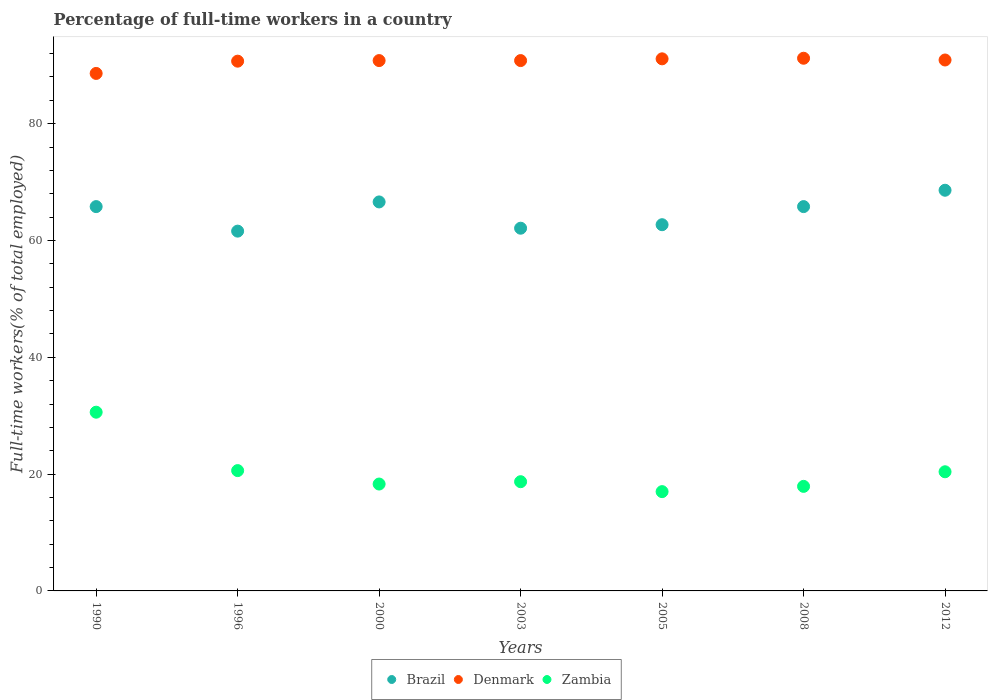Is the number of dotlines equal to the number of legend labels?
Provide a succinct answer. Yes. What is the percentage of full-time workers in Zambia in 2005?
Give a very brief answer. 17. Across all years, what is the maximum percentage of full-time workers in Zambia?
Provide a short and direct response. 30.6. Across all years, what is the minimum percentage of full-time workers in Denmark?
Your response must be concise. 88.6. What is the total percentage of full-time workers in Zambia in the graph?
Ensure brevity in your answer.  143.5. What is the difference between the percentage of full-time workers in Zambia in 2005 and that in 2012?
Offer a very short reply. -3.4. What is the difference between the percentage of full-time workers in Zambia in 2000 and the percentage of full-time workers in Brazil in 2012?
Provide a short and direct response. -50.3. What is the average percentage of full-time workers in Denmark per year?
Offer a terse response. 90.59. In the year 2005, what is the difference between the percentage of full-time workers in Zambia and percentage of full-time workers in Denmark?
Your answer should be very brief. -74.1. In how many years, is the percentage of full-time workers in Brazil greater than 48 %?
Offer a very short reply. 7. What is the ratio of the percentage of full-time workers in Denmark in 2005 to that in 2008?
Give a very brief answer. 1. Is the percentage of full-time workers in Denmark in 2000 less than that in 2003?
Keep it short and to the point. No. Is the difference between the percentage of full-time workers in Zambia in 1996 and 2000 greater than the difference between the percentage of full-time workers in Denmark in 1996 and 2000?
Give a very brief answer. Yes. What is the difference between the highest and the lowest percentage of full-time workers in Zambia?
Give a very brief answer. 13.6. Is the sum of the percentage of full-time workers in Zambia in 2008 and 2012 greater than the maximum percentage of full-time workers in Brazil across all years?
Provide a short and direct response. No. Does the percentage of full-time workers in Denmark monotonically increase over the years?
Offer a very short reply. No. Is the percentage of full-time workers in Brazil strictly less than the percentage of full-time workers in Zambia over the years?
Offer a very short reply. No. How many dotlines are there?
Your response must be concise. 3. How many years are there in the graph?
Offer a very short reply. 7. Where does the legend appear in the graph?
Provide a succinct answer. Bottom center. How many legend labels are there?
Ensure brevity in your answer.  3. What is the title of the graph?
Make the answer very short. Percentage of full-time workers in a country. What is the label or title of the X-axis?
Give a very brief answer. Years. What is the label or title of the Y-axis?
Keep it short and to the point. Full-time workers(% of total employed). What is the Full-time workers(% of total employed) in Brazil in 1990?
Provide a succinct answer. 65.8. What is the Full-time workers(% of total employed) of Denmark in 1990?
Your answer should be compact. 88.6. What is the Full-time workers(% of total employed) in Zambia in 1990?
Your answer should be compact. 30.6. What is the Full-time workers(% of total employed) in Brazil in 1996?
Offer a terse response. 61.6. What is the Full-time workers(% of total employed) in Denmark in 1996?
Provide a short and direct response. 90.7. What is the Full-time workers(% of total employed) in Zambia in 1996?
Provide a succinct answer. 20.6. What is the Full-time workers(% of total employed) in Brazil in 2000?
Offer a very short reply. 66.6. What is the Full-time workers(% of total employed) in Denmark in 2000?
Give a very brief answer. 90.8. What is the Full-time workers(% of total employed) of Zambia in 2000?
Offer a very short reply. 18.3. What is the Full-time workers(% of total employed) in Brazil in 2003?
Keep it short and to the point. 62.1. What is the Full-time workers(% of total employed) in Denmark in 2003?
Offer a very short reply. 90.8. What is the Full-time workers(% of total employed) in Zambia in 2003?
Keep it short and to the point. 18.7. What is the Full-time workers(% of total employed) in Brazil in 2005?
Your answer should be very brief. 62.7. What is the Full-time workers(% of total employed) in Denmark in 2005?
Give a very brief answer. 91.1. What is the Full-time workers(% of total employed) in Zambia in 2005?
Make the answer very short. 17. What is the Full-time workers(% of total employed) of Brazil in 2008?
Provide a short and direct response. 65.8. What is the Full-time workers(% of total employed) in Denmark in 2008?
Your response must be concise. 91.2. What is the Full-time workers(% of total employed) in Zambia in 2008?
Offer a terse response. 17.9. What is the Full-time workers(% of total employed) in Brazil in 2012?
Your answer should be very brief. 68.6. What is the Full-time workers(% of total employed) of Denmark in 2012?
Make the answer very short. 90.9. What is the Full-time workers(% of total employed) in Zambia in 2012?
Your answer should be very brief. 20.4. Across all years, what is the maximum Full-time workers(% of total employed) of Brazil?
Make the answer very short. 68.6. Across all years, what is the maximum Full-time workers(% of total employed) of Denmark?
Make the answer very short. 91.2. Across all years, what is the maximum Full-time workers(% of total employed) in Zambia?
Ensure brevity in your answer.  30.6. Across all years, what is the minimum Full-time workers(% of total employed) of Brazil?
Give a very brief answer. 61.6. Across all years, what is the minimum Full-time workers(% of total employed) in Denmark?
Your answer should be compact. 88.6. Across all years, what is the minimum Full-time workers(% of total employed) of Zambia?
Ensure brevity in your answer.  17. What is the total Full-time workers(% of total employed) in Brazil in the graph?
Keep it short and to the point. 453.2. What is the total Full-time workers(% of total employed) in Denmark in the graph?
Provide a short and direct response. 634.1. What is the total Full-time workers(% of total employed) of Zambia in the graph?
Your response must be concise. 143.5. What is the difference between the Full-time workers(% of total employed) of Brazil in 1990 and that in 1996?
Keep it short and to the point. 4.2. What is the difference between the Full-time workers(% of total employed) in Denmark in 1990 and that in 1996?
Offer a very short reply. -2.1. What is the difference between the Full-time workers(% of total employed) of Denmark in 1990 and that in 2000?
Give a very brief answer. -2.2. What is the difference between the Full-time workers(% of total employed) in Zambia in 1990 and that in 2003?
Your answer should be very brief. 11.9. What is the difference between the Full-time workers(% of total employed) of Brazil in 1990 and that in 2005?
Your answer should be very brief. 3.1. What is the difference between the Full-time workers(% of total employed) of Denmark in 1990 and that in 2005?
Offer a terse response. -2.5. What is the difference between the Full-time workers(% of total employed) of Zambia in 1990 and that in 2005?
Provide a succinct answer. 13.6. What is the difference between the Full-time workers(% of total employed) in Brazil in 1990 and that in 2008?
Ensure brevity in your answer.  0. What is the difference between the Full-time workers(% of total employed) in Zambia in 1990 and that in 2008?
Keep it short and to the point. 12.7. What is the difference between the Full-time workers(% of total employed) in Brazil in 1990 and that in 2012?
Make the answer very short. -2.8. What is the difference between the Full-time workers(% of total employed) in Denmark in 1990 and that in 2012?
Your answer should be very brief. -2.3. What is the difference between the Full-time workers(% of total employed) in Brazil in 1996 and that in 2000?
Offer a very short reply. -5. What is the difference between the Full-time workers(% of total employed) in Zambia in 1996 and that in 2000?
Your response must be concise. 2.3. What is the difference between the Full-time workers(% of total employed) in Brazil in 1996 and that in 2003?
Your answer should be very brief. -0.5. What is the difference between the Full-time workers(% of total employed) of Denmark in 1996 and that in 2003?
Offer a terse response. -0.1. What is the difference between the Full-time workers(% of total employed) of Denmark in 1996 and that in 2005?
Give a very brief answer. -0.4. What is the difference between the Full-time workers(% of total employed) in Brazil in 1996 and that in 2008?
Offer a very short reply. -4.2. What is the difference between the Full-time workers(% of total employed) in Brazil in 1996 and that in 2012?
Your response must be concise. -7. What is the difference between the Full-time workers(% of total employed) of Denmark in 1996 and that in 2012?
Offer a very short reply. -0.2. What is the difference between the Full-time workers(% of total employed) of Zambia in 1996 and that in 2012?
Keep it short and to the point. 0.2. What is the difference between the Full-time workers(% of total employed) in Denmark in 2000 and that in 2003?
Make the answer very short. 0. What is the difference between the Full-time workers(% of total employed) of Denmark in 2000 and that in 2005?
Keep it short and to the point. -0.3. What is the difference between the Full-time workers(% of total employed) in Zambia in 2000 and that in 2005?
Your answer should be compact. 1.3. What is the difference between the Full-time workers(% of total employed) in Zambia in 2000 and that in 2008?
Offer a very short reply. 0.4. What is the difference between the Full-time workers(% of total employed) in Denmark in 2000 and that in 2012?
Give a very brief answer. -0.1. What is the difference between the Full-time workers(% of total employed) of Brazil in 2003 and that in 2005?
Provide a succinct answer. -0.6. What is the difference between the Full-time workers(% of total employed) in Zambia in 2003 and that in 2005?
Make the answer very short. 1.7. What is the difference between the Full-time workers(% of total employed) in Brazil in 2003 and that in 2008?
Give a very brief answer. -3.7. What is the difference between the Full-time workers(% of total employed) of Denmark in 2003 and that in 2008?
Ensure brevity in your answer.  -0.4. What is the difference between the Full-time workers(% of total employed) of Zambia in 2003 and that in 2012?
Ensure brevity in your answer.  -1.7. What is the difference between the Full-time workers(% of total employed) in Denmark in 2005 and that in 2008?
Give a very brief answer. -0.1. What is the difference between the Full-time workers(% of total employed) in Zambia in 2005 and that in 2008?
Offer a very short reply. -0.9. What is the difference between the Full-time workers(% of total employed) of Brazil in 2005 and that in 2012?
Offer a terse response. -5.9. What is the difference between the Full-time workers(% of total employed) in Zambia in 2005 and that in 2012?
Your answer should be very brief. -3.4. What is the difference between the Full-time workers(% of total employed) of Brazil in 1990 and the Full-time workers(% of total employed) of Denmark in 1996?
Provide a short and direct response. -24.9. What is the difference between the Full-time workers(% of total employed) of Brazil in 1990 and the Full-time workers(% of total employed) of Zambia in 1996?
Keep it short and to the point. 45.2. What is the difference between the Full-time workers(% of total employed) in Brazil in 1990 and the Full-time workers(% of total employed) in Zambia in 2000?
Offer a terse response. 47.5. What is the difference between the Full-time workers(% of total employed) in Denmark in 1990 and the Full-time workers(% of total employed) in Zambia in 2000?
Keep it short and to the point. 70.3. What is the difference between the Full-time workers(% of total employed) of Brazil in 1990 and the Full-time workers(% of total employed) of Zambia in 2003?
Provide a short and direct response. 47.1. What is the difference between the Full-time workers(% of total employed) in Denmark in 1990 and the Full-time workers(% of total employed) in Zambia in 2003?
Provide a short and direct response. 69.9. What is the difference between the Full-time workers(% of total employed) in Brazil in 1990 and the Full-time workers(% of total employed) in Denmark in 2005?
Provide a short and direct response. -25.3. What is the difference between the Full-time workers(% of total employed) in Brazil in 1990 and the Full-time workers(% of total employed) in Zambia in 2005?
Provide a short and direct response. 48.8. What is the difference between the Full-time workers(% of total employed) of Denmark in 1990 and the Full-time workers(% of total employed) of Zambia in 2005?
Offer a terse response. 71.6. What is the difference between the Full-time workers(% of total employed) of Brazil in 1990 and the Full-time workers(% of total employed) of Denmark in 2008?
Provide a short and direct response. -25.4. What is the difference between the Full-time workers(% of total employed) in Brazil in 1990 and the Full-time workers(% of total employed) in Zambia in 2008?
Ensure brevity in your answer.  47.9. What is the difference between the Full-time workers(% of total employed) of Denmark in 1990 and the Full-time workers(% of total employed) of Zambia in 2008?
Ensure brevity in your answer.  70.7. What is the difference between the Full-time workers(% of total employed) in Brazil in 1990 and the Full-time workers(% of total employed) in Denmark in 2012?
Your answer should be very brief. -25.1. What is the difference between the Full-time workers(% of total employed) of Brazil in 1990 and the Full-time workers(% of total employed) of Zambia in 2012?
Make the answer very short. 45.4. What is the difference between the Full-time workers(% of total employed) in Denmark in 1990 and the Full-time workers(% of total employed) in Zambia in 2012?
Make the answer very short. 68.2. What is the difference between the Full-time workers(% of total employed) in Brazil in 1996 and the Full-time workers(% of total employed) in Denmark in 2000?
Your response must be concise. -29.2. What is the difference between the Full-time workers(% of total employed) in Brazil in 1996 and the Full-time workers(% of total employed) in Zambia in 2000?
Keep it short and to the point. 43.3. What is the difference between the Full-time workers(% of total employed) in Denmark in 1996 and the Full-time workers(% of total employed) in Zambia in 2000?
Offer a very short reply. 72.4. What is the difference between the Full-time workers(% of total employed) of Brazil in 1996 and the Full-time workers(% of total employed) of Denmark in 2003?
Make the answer very short. -29.2. What is the difference between the Full-time workers(% of total employed) of Brazil in 1996 and the Full-time workers(% of total employed) of Zambia in 2003?
Give a very brief answer. 42.9. What is the difference between the Full-time workers(% of total employed) in Brazil in 1996 and the Full-time workers(% of total employed) in Denmark in 2005?
Give a very brief answer. -29.5. What is the difference between the Full-time workers(% of total employed) of Brazil in 1996 and the Full-time workers(% of total employed) of Zambia in 2005?
Your response must be concise. 44.6. What is the difference between the Full-time workers(% of total employed) in Denmark in 1996 and the Full-time workers(% of total employed) in Zambia in 2005?
Offer a very short reply. 73.7. What is the difference between the Full-time workers(% of total employed) of Brazil in 1996 and the Full-time workers(% of total employed) of Denmark in 2008?
Your answer should be very brief. -29.6. What is the difference between the Full-time workers(% of total employed) of Brazil in 1996 and the Full-time workers(% of total employed) of Zambia in 2008?
Offer a very short reply. 43.7. What is the difference between the Full-time workers(% of total employed) in Denmark in 1996 and the Full-time workers(% of total employed) in Zambia in 2008?
Ensure brevity in your answer.  72.8. What is the difference between the Full-time workers(% of total employed) of Brazil in 1996 and the Full-time workers(% of total employed) of Denmark in 2012?
Ensure brevity in your answer.  -29.3. What is the difference between the Full-time workers(% of total employed) of Brazil in 1996 and the Full-time workers(% of total employed) of Zambia in 2012?
Offer a very short reply. 41.2. What is the difference between the Full-time workers(% of total employed) of Denmark in 1996 and the Full-time workers(% of total employed) of Zambia in 2012?
Your answer should be compact. 70.3. What is the difference between the Full-time workers(% of total employed) in Brazil in 2000 and the Full-time workers(% of total employed) in Denmark in 2003?
Give a very brief answer. -24.2. What is the difference between the Full-time workers(% of total employed) of Brazil in 2000 and the Full-time workers(% of total employed) of Zambia in 2003?
Your answer should be very brief. 47.9. What is the difference between the Full-time workers(% of total employed) of Denmark in 2000 and the Full-time workers(% of total employed) of Zambia in 2003?
Keep it short and to the point. 72.1. What is the difference between the Full-time workers(% of total employed) of Brazil in 2000 and the Full-time workers(% of total employed) of Denmark in 2005?
Offer a very short reply. -24.5. What is the difference between the Full-time workers(% of total employed) in Brazil in 2000 and the Full-time workers(% of total employed) in Zambia in 2005?
Keep it short and to the point. 49.6. What is the difference between the Full-time workers(% of total employed) of Denmark in 2000 and the Full-time workers(% of total employed) of Zambia in 2005?
Keep it short and to the point. 73.8. What is the difference between the Full-time workers(% of total employed) of Brazil in 2000 and the Full-time workers(% of total employed) of Denmark in 2008?
Keep it short and to the point. -24.6. What is the difference between the Full-time workers(% of total employed) in Brazil in 2000 and the Full-time workers(% of total employed) in Zambia in 2008?
Offer a very short reply. 48.7. What is the difference between the Full-time workers(% of total employed) in Denmark in 2000 and the Full-time workers(% of total employed) in Zambia in 2008?
Give a very brief answer. 72.9. What is the difference between the Full-time workers(% of total employed) of Brazil in 2000 and the Full-time workers(% of total employed) of Denmark in 2012?
Keep it short and to the point. -24.3. What is the difference between the Full-time workers(% of total employed) of Brazil in 2000 and the Full-time workers(% of total employed) of Zambia in 2012?
Offer a terse response. 46.2. What is the difference between the Full-time workers(% of total employed) in Denmark in 2000 and the Full-time workers(% of total employed) in Zambia in 2012?
Give a very brief answer. 70.4. What is the difference between the Full-time workers(% of total employed) in Brazil in 2003 and the Full-time workers(% of total employed) in Denmark in 2005?
Offer a terse response. -29. What is the difference between the Full-time workers(% of total employed) in Brazil in 2003 and the Full-time workers(% of total employed) in Zambia in 2005?
Your answer should be very brief. 45.1. What is the difference between the Full-time workers(% of total employed) in Denmark in 2003 and the Full-time workers(% of total employed) in Zambia in 2005?
Provide a short and direct response. 73.8. What is the difference between the Full-time workers(% of total employed) of Brazil in 2003 and the Full-time workers(% of total employed) of Denmark in 2008?
Give a very brief answer. -29.1. What is the difference between the Full-time workers(% of total employed) in Brazil in 2003 and the Full-time workers(% of total employed) in Zambia in 2008?
Give a very brief answer. 44.2. What is the difference between the Full-time workers(% of total employed) in Denmark in 2003 and the Full-time workers(% of total employed) in Zambia in 2008?
Your answer should be compact. 72.9. What is the difference between the Full-time workers(% of total employed) of Brazil in 2003 and the Full-time workers(% of total employed) of Denmark in 2012?
Offer a terse response. -28.8. What is the difference between the Full-time workers(% of total employed) in Brazil in 2003 and the Full-time workers(% of total employed) in Zambia in 2012?
Make the answer very short. 41.7. What is the difference between the Full-time workers(% of total employed) in Denmark in 2003 and the Full-time workers(% of total employed) in Zambia in 2012?
Offer a very short reply. 70.4. What is the difference between the Full-time workers(% of total employed) in Brazil in 2005 and the Full-time workers(% of total employed) in Denmark in 2008?
Give a very brief answer. -28.5. What is the difference between the Full-time workers(% of total employed) of Brazil in 2005 and the Full-time workers(% of total employed) of Zambia in 2008?
Keep it short and to the point. 44.8. What is the difference between the Full-time workers(% of total employed) of Denmark in 2005 and the Full-time workers(% of total employed) of Zambia in 2008?
Offer a terse response. 73.2. What is the difference between the Full-time workers(% of total employed) of Brazil in 2005 and the Full-time workers(% of total employed) of Denmark in 2012?
Keep it short and to the point. -28.2. What is the difference between the Full-time workers(% of total employed) of Brazil in 2005 and the Full-time workers(% of total employed) of Zambia in 2012?
Ensure brevity in your answer.  42.3. What is the difference between the Full-time workers(% of total employed) in Denmark in 2005 and the Full-time workers(% of total employed) in Zambia in 2012?
Give a very brief answer. 70.7. What is the difference between the Full-time workers(% of total employed) in Brazil in 2008 and the Full-time workers(% of total employed) in Denmark in 2012?
Give a very brief answer. -25.1. What is the difference between the Full-time workers(% of total employed) of Brazil in 2008 and the Full-time workers(% of total employed) of Zambia in 2012?
Give a very brief answer. 45.4. What is the difference between the Full-time workers(% of total employed) in Denmark in 2008 and the Full-time workers(% of total employed) in Zambia in 2012?
Your answer should be compact. 70.8. What is the average Full-time workers(% of total employed) in Brazil per year?
Your answer should be compact. 64.74. What is the average Full-time workers(% of total employed) of Denmark per year?
Offer a terse response. 90.59. In the year 1990, what is the difference between the Full-time workers(% of total employed) in Brazil and Full-time workers(% of total employed) in Denmark?
Provide a succinct answer. -22.8. In the year 1990, what is the difference between the Full-time workers(% of total employed) of Brazil and Full-time workers(% of total employed) of Zambia?
Offer a very short reply. 35.2. In the year 1996, what is the difference between the Full-time workers(% of total employed) of Brazil and Full-time workers(% of total employed) of Denmark?
Offer a very short reply. -29.1. In the year 1996, what is the difference between the Full-time workers(% of total employed) of Denmark and Full-time workers(% of total employed) of Zambia?
Your response must be concise. 70.1. In the year 2000, what is the difference between the Full-time workers(% of total employed) of Brazil and Full-time workers(% of total employed) of Denmark?
Your answer should be very brief. -24.2. In the year 2000, what is the difference between the Full-time workers(% of total employed) of Brazil and Full-time workers(% of total employed) of Zambia?
Provide a succinct answer. 48.3. In the year 2000, what is the difference between the Full-time workers(% of total employed) of Denmark and Full-time workers(% of total employed) of Zambia?
Offer a terse response. 72.5. In the year 2003, what is the difference between the Full-time workers(% of total employed) in Brazil and Full-time workers(% of total employed) in Denmark?
Keep it short and to the point. -28.7. In the year 2003, what is the difference between the Full-time workers(% of total employed) in Brazil and Full-time workers(% of total employed) in Zambia?
Keep it short and to the point. 43.4. In the year 2003, what is the difference between the Full-time workers(% of total employed) in Denmark and Full-time workers(% of total employed) in Zambia?
Your answer should be compact. 72.1. In the year 2005, what is the difference between the Full-time workers(% of total employed) of Brazil and Full-time workers(% of total employed) of Denmark?
Give a very brief answer. -28.4. In the year 2005, what is the difference between the Full-time workers(% of total employed) of Brazil and Full-time workers(% of total employed) of Zambia?
Provide a short and direct response. 45.7. In the year 2005, what is the difference between the Full-time workers(% of total employed) in Denmark and Full-time workers(% of total employed) in Zambia?
Ensure brevity in your answer.  74.1. In the year 2008, what is the difference between the Full-time workers(% of total employed) of Brazil and Full-time workers(% of total employed) of Denmark?
Keep it short and to the point. -25.4. In the year 2008, what is the difference between the Full-time workers(% of total employed) in Brazil and Full-time workers(% of total employed) in Zambia?
Keep it short and to the point. 47.9. In the year 2008, what is the difference between the Full-time workers(% of total employed) in Denmark and Full-time workers(% of total employed) in Zambia?
Give a very brief answer. 73.3. In the year 2012, what is the difference between the Full-time workers(% of total employed) of Brazil and Full-time workers(% of total employed) of Denmark?
Your answer should be compact. -22.3. In the year 2012, what is the difference between the Full-time workers(% of total employed) in Brazil and Full-time workers(% of total employed) in Zambia?
Provide a short and direct response. 48.2. In the year 2012, what is the difference between the Full-time workers(% of total employed) in Denmark and Full-time workers(% of total employed) in Zambia?
Make the answer very short. 70.5. What is the ratio of the Full-time workers(% of total employed) in Brazil in 1990 to that in 1996?
Keep it short and to the point. 1.07. What is the ratio of the Full-time workers(% of total employed) of Denmark in 1990 to that in 1996?
Your answer should be compact. 0.98. What is the ratio of the Full-time workers(% of total employed) in Zambia in 1990 to that in 1996?
Your answer should be compact. 1.49. What is the ratio of the Full-time workers(% of total employed) in Brazil in 1990 to that in 2000?
Offer a terse response. 0.99. What is the ratio of the Full-time workers(% of total employed) in Denmark in 1990 to that in 2000?
Your answer should be compact. 0.98. What is the ratio of the Full-time workers(% of total employed) in Zambia in 1990 to that in 2000?
Your response must be concise. 1.67. What is the ratio of the Full-time workers(% of total employed) of Brazil in 1990 to that in 2003?
Provide a succinct answer. 1.06. What is the ratio of the Full-time workers(% of total employed) in Denmark in 1990 to that in 2003?
Your answer should be very brief. 0.98. What is the ratio of the Full-time workers(% of total employed) in Zambia in 1990 to that in 2003?
Keep it short and to the point. 1.64. What is the ratio of the Full-time workers(% of total employed) in Brazil in 1990 to that in 2005?
Your answer should be compact. 1.05. What is the ratio of the Full-time workers(% of total employed) of Denmark in 1990 to that in 2005?
Make the answer very short. 0.97. What is the ratio of the Full-time workers(% of total employed) in Zambia in 1990 to that in 2005?
Make the answer very short. 1.8. What is the ratio of the Full-time workers(% of total employed) in Denmark in 1990 to that in 2008?
Your response must be concise. 0.97. What is the ratio of the Full-time workers(% of total employed) in Zambia in 1990 to that in 2008?
Give a very brief answer. 1.71. What is the ratio of the Full-time workers(% of total employed) in Brazil in 1990 to that in 2012?
Provide a short and direct response. 0.96. What is the ratio of the Full-time workers(% of total employed) in Denmark in 1990 to that in 2012?
Offer a terse response. 0.97. What is the ratio of the Full-time workers(% of total employed) of Brazil in 1996 to that in 2000?
Keep it short and to the point. 0.92. What is the ratio of the Full-time workers(% of total employed) in Zambia in 1996 to that in 2000?
Offer a terse response. 1.13. What is the ratio of the Full-time workers(% of total employed) in Zambia in 1996 to that in 2003?
Your response must be concise. 1.1. What is the ratio of the Full-time workers(% of total employed) of Brazil in 1996 to that in 2005?
Offer a very short reply. 0.98. What is the ratio of the Full-time workers(% of total employed) of Denmark in 1996 to that in 2005?
Your answer should be compact. 1. What is the ratio of the Full-time workers(% of total employed) of Zambia in 1996 to that in 2005?
Ensure brevity in your answer.  1.21. What is the ratio of the Full-time workers(% of total employed) of Brazil in 1996 to that in 2008?
Your answer should be compact. 0.94. What is the ratio of the Full-time workers(% of total employed) in Denmark in 1996 to that in 2008?
Offer a very short reply. 0.99. What is the ratio of the Full-time workers(% of total employed) in Zambia in 1996 to that in 2008?
Offer a terse response. 1.15. What is the ratio of the Full-time workers(% of total employed) in Brazil in 1996 to that in 2012?
Give a very brief answer. 0.9. What is the ratio of the Full-time workers(% of total employed) of Zambia in 1996 to that in 2012?
Make the answer very short. 1.01. What is the ratio of the Full-time workers(% of total employed) in Brazil in 2000 to that in 2003?
Keep it short and to the point. 1.07. What is the ratio of the Full-time workers(% of total employed) in Zambia in 2000 to that in 2003?
Your answer should be very brief. 0.98. What is the ratio of the Full-time workers(% of total employed) in Brazil in 2000 to that in 2005?
Your answer should be compact. 1.06. What is the ratio of the Full-time workers(% of total employed) of Denmark in 2000 to that in 2005?
Your response must be concise. 1. What is the ratio of the Full-time workers(% of total employed) of Zambia in 2000 to that in 2005?
Provide a succinct answer. 1.08. What is the ratio of the Full-time workers(% of total employed) of Brazil in 2000 to that in 2008?
Make the answer very short. 1.01. What is the ratio of the Full-time workers(% of total employed) of Denmark in 2000 to that in 2008?
Offer a very short reply. 1. What is the ratio of the Full-time workers(% of total employed) in Zambia in 2000 to that in 2008?
Give a very brief answer. 1.02. What is the ratio of the Full-time workers(% of total employed) in Brazil in 2000 to that in 2012?
Make the answer very short. 0.97. What is the ratio of the Full-time workers(% of total employed) in Denmark in 2000 to that in 2012?
Offer a very short reply. 1. What is the ratio of the Full-time workers(% of total employed) of Zambia in 2000 to that in 2012?
Your answer should be compact. 0.9. What is the ratio of the Full-time workers(% of total employed) of Brazil in 2003 to that in 2008?
Make the answer very short. 0.94. What is the ratio of the Full-time workers(% of total employed) of Denmark in 2003 to that in 2008?
Keep it short and to the point. 1. What is the ratio of the Full-time workers(% of total employed) in Zambia in 2003 to that in 2008?
Ensure brevity in your answer.  1.04. What is the ratio of the Full-time workers(% of total employed) of Brazil in 2003 to that in 2012?
Offer a very short reply. 0.91. What is the ratio of the Full-time workers(% of total employed) of Zambia in 2003 to that in 2012?
Keep it short and to the point. 0.92. What is the ratio of the Full-time workers(% of total employed) in Brazil in 2005 to that in 2008?
Offer a very short reply. 0.95. What is the ratio of the Full-time workers(% of total employed) of Zambia in 2005 to that in 2008?
Your response must be concise. 0.95. What is the ratio of the Full-time workers(% of total employed) of Brazil in 2005 to that in 2012?
Make the answer very short. 0.91. What is the ratio of the Full-time workers(% of total employed) in Denmark in 2005 to that in 2012?
Your response must be concise. 1. What is the ratio of the Full-time workers(% of total employed) of Zambia in 2005 to that in 2012?
Offer a terse response. 0.83. What is the ratio of the Full-time workers(% of total employed) of Brazil in 2008 to that in 2012?
Your answer should be compact. 0.96. What is the ratio of the Full-time workers(% of total employed) in Denmark in 2008 to that in 2012?
Keep it short and to the point. 1. What is the ratio of the Full-time workers(% of total employed) of Zambia in 2008 to that in 2012?
Your response must be concise. 0.88. What is the difference between the highest and the second highest Full-time workers(% of total employed) of Zambia?
Offer a terse response. 10. What is the difference between the highest and the lowest Full-time workers(% of total employed) of Brazil?
Your answer should be very brief. 7. What is the difference between the highest and the lowest Full-time workers(% of total employed) of Denmark?
Your answer should be very brief. 2.6. 